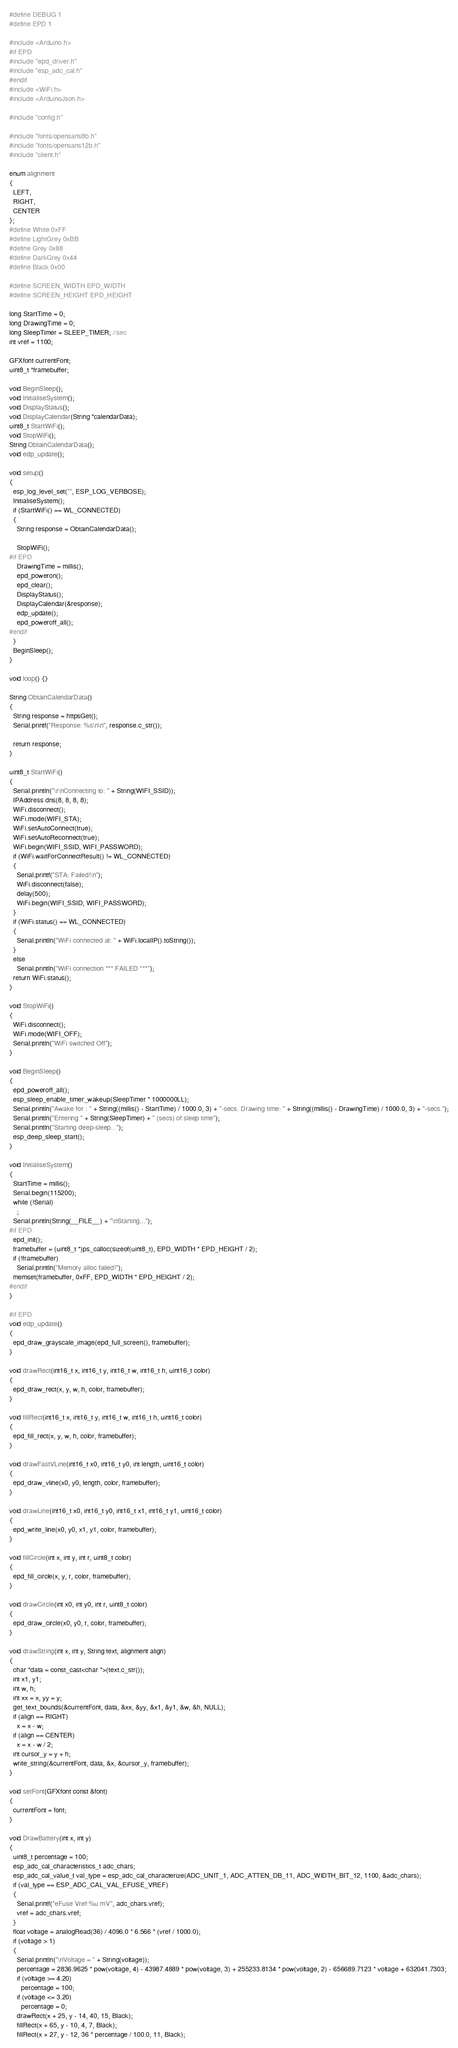<code> <loc_0><loc_0><loc_500><loc_500><_C++_>#define DEBUG 1
#define EPD 1

#include <Arduino.h>
#if EPD
#include "epd_driver.h"
#include "esp_adc_cal.h"
#endif
#include <WiFi.h>
#include <ArduinoJson.h>

#include "config.h"

#include "fonts/opensans8b.h"
#include "fonts/opensans12b.h"
#include "client.h"

enum alignment
{
  LEFT,
  RIGHT,
  CENTER
};
#define White 0xFF
#define LightGrey 0xBB
#define Grey 0x88
#define DarkGrey 0x44
#define Black 0x00

#define SCREEN_WIDTH EPD_WIDTH
#define SCREEN_HEIGHT EPD_HEIGHT

long StartTime = 0;
long DrawingTime = 0;
long SleepTimer = SLEEP_TIMER; //sec
int vref = 1100;

GFXfont currentFont;
uint8_t *framebuffer;

void BeginSleep();
void InitialiseSystem();
void DisplayStatus();
void DisplayCalendar(String *calendarData);
uint8_t StartWiFi();
void StopWiFi();
String ObtainCalendarData();
void edp_update();

void setup()
{
  esp_log_level_set("", ESP_LOG_VERBOSE);
  InitialiseSystem();
  if (StartWiFi() == WL_CONNECTED)
  {
    String response = ObtainCalendarData();

    StopWiFi();
#if EPD
    DrawingTime = millis();
    epd_poweron();
    epd_clear();
    DisplayStatus();
    DisplayCalendar(&response);
    edp_update();
    epd_poweroff_all();
#endif
  }
  BeginSleep();
}

void loop() {}

String ObtainCalendarData()
{
  String response = httpsGet();
  Serial.printf("Response: %s\n\n", response.c_str());

  return response;
}

uint8_t StartWiFi()
{
  Serial.println("\r\nConnecting to: " + String(WIFI_SSID));
  IPAddress dns(8, 8, 8, 8);
  WiFi.disconnect();
  WiFi.mode(WIFI_STA);
  WiFi.setAutoConnect(true);
  WiFi.setAutoReconnect(true);
  WiFi.begin(WIFI_SSID, WIFI_PASSWORD);
  if (WiFi.waitForConnectResult() != WL_CONNECTED)
  {
    Serial.printf("STA: Failed!\n");
    WiFi.disconnect(false);
    delay(500);
    WiFi.begin(WIFI_SSID, WIFI_PASSWORD);
  }
  if (WiFi.status() == WL_CONNECTED)
  {
    Serial.println("WiFi connected at: " + WiFi.localIP().toString());
  }
  else
    Serial.println("WiFi connection *** FAILED ***");
  return WiFi.status();
}

void StopWiFi()
{
  WiFi.disconnect();
  WiFi.mode(WIFI_OFF);
  Serial.println("WiFi switched Off");
}

void BeginSleep()
{
  epd_poweroff_all();
  esp_sleep_enable_timer_wakeup(SleepTimer * 1000000LL);
  Serial.println("Awake for : " + String((millis() - StartTime) / 1000.0, 3) + "-secs. Drawing time: " + String((millis() - DrawingTime) / 1000.0, 3) + "-secs.");
  Serial.println("Entering " + String(SleepTimer) + " (secs) of sleep time");
  Serial.println("Starting deep-sleep...");
  esp_deep_sleep_start();
}

void InitialiseSystem()
{
  StartTime = millis();
  Serial.begin(115200);
  while (!Serial)
    ;
  Serial.println(String(__FILE__) + "\nStarting...");
#if EPD
  epd_init();
  framebuffer = (uint8_t *)ps_calloc(sizeof(uint8_t), EPD_WIDTH * EPD_HEIGHT / 2);
  if (!framebuffer)
    Serial.println("Memory alloc failed!");
  memset(framebuffer, 0xFF, EPD_WIDTH * EPD_HEIGHT / 2);
#endif
}

#if EPD
void edp_update()
{
  epd_draw_grayscale_image(epd_full_screen(), framebuffer);
}

void drawRect(int16_t x, int16_t y, int16_t w, int16_t h, uint16_t color)
{
  epd_draw_rect(x, y, w, h, color, framebuffer);
}

void fillRect(int16_t x, int16_t y, int16_t w, int16_t h, uint16_t color)
{
  epd_fill_rect(x, y, w, h, color, framebuffer);
}

void drawFastVLine(int16_t x0, int16_t y0, int length, uint16_t color)
{
  epd_draw_vline(x0, y0, length, color, framebuffer);
}

void drawLine(int16_t x0, int16_t y0, int16_t x1, int16_t y1, uint16_t color)
{
  epd_write_line(x0, y0, x1, y1, color, framebuffer);
}

void fillCircle(int x, int y, int r, uint8_t color)
{
  epd_fill_circle(x, y, r, color, framebuffer);
}

void drawCircle(int x0, int y0, int r, uint8_t color)
{
  epd_draw_circle(x0, y0, r, color, framebuffer);
}

void drawString(int x, int y, String text, alignment align)
{
  char *data = const_cast<char *>(text.c_str());
  int x1, y1;
  int w, h;
  int xx = x, yy = y;
  get_text_bounds(&currentFont, data, &xx, &yy, &x1, &y1, &w, &h, NULL);
  if (align == RIGHT)
    x = x - w;
  if (align == CENTER)
    x = x - w / 2;
  int cursor_y = y + h;
  write_string(&currentFont, data, &x, &cursor_y, framebuffer);
}

void setFont(GFXfont const &font)
{
  currentFont = font;
}

void DrawBattery(int x, int y)
{
  uint8_t percentage = 100;
  esp_adc_cal_characteristics_t adc_chars;
  esp_adc_cal_value_t val_type = esp_adc_cal_characterize(ADC_UNIT_1, ADC_ATTEN_DB_11, ADC_WIDTH_BIT_12, 1100, &adc_chars);
  if (val_type == ESP_ADC_CAL_VAL_EFUSE_VREF)
  {
    Serial.printf("eFuse Vref:%u mV", adc_chars.vref);
    vref = adc_chars.vref;
  }
  float voltage = analogRead(36) / 4096.0 * 6.566 * (vref / 1000.0);
  if (voltage > 1)
  {
    Serial.println("\nVoltage = " + String(voltage));
    percentage = 2836.9625 * pow(voltage, 4) - 43987.4889 * pow(voltage, 3) + 255233.8134 * pow(voltage, 2) - 656689.7123 * voltage + 632041.7303;
    if (voltage >= 4.20)
      percentage = 100;
    if (voltage <= 3.20)
      percentage = 0;
    drawRect(x + 25, y - 14, 40, 15, Black);
    fillRect(x + 65, y - 10, 4, 7, Black);
    fillRect(x + 27, y - 12, 36 * percentage / 100.0, 11, Black);</code> 